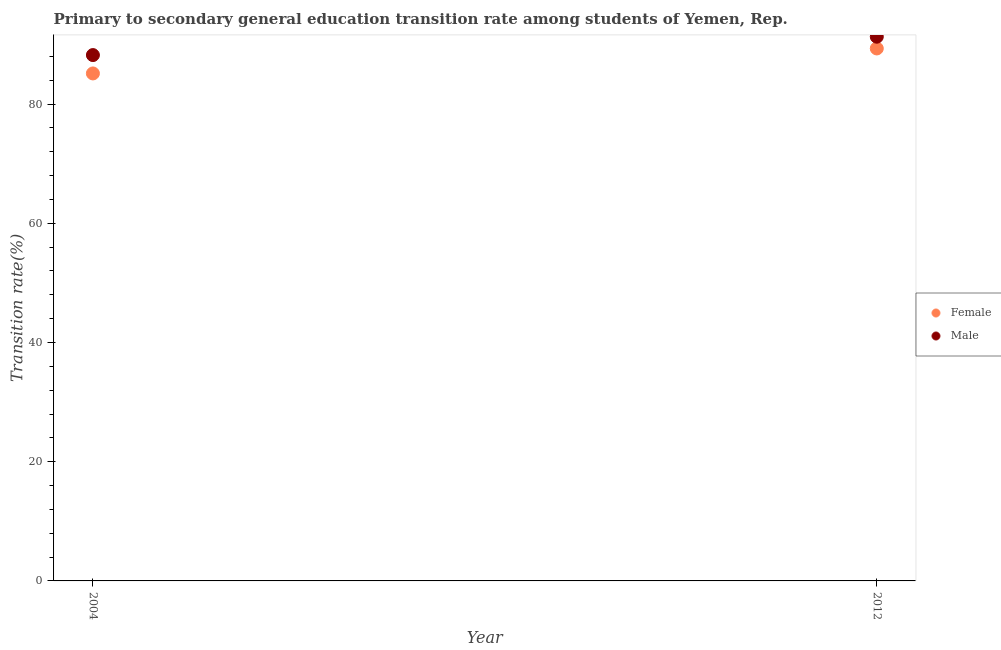How many different coloured dotlines are there?
Give a very brief answer. 2. What is the transition rate among male students in 2012?
Keep it short and to the point. 91.3. Across all years, what is the maximum transition rate among male students?
Provide a short and direct response. 91.3. Across all years, what is the minimum transition rate among male students?
Your answer should be very brief. 88.22. In which year was the transition rate among female students maximum?
Provide a short and direct response. 2012. What is the total transition rate among male students in the graph?
Keep it short and to the point. 179.51. What is the difference between the transition rate among male students in 2004 and that in 2012?
Your response must be concise. -3.08. What is the difference between the transition rate among male students in 2012 and the transition rate among female students in 2004?
Your answer should be very brief. 6.16. What is the average transition rate among male students per year?
Ensure brevity in your answer.  89.76. In the year 2012, what is the difference between the transition rate among male students and transition rate among female students?
Offer a very short reply. 1.97. In how many years, is the transition rate among female students greater than 60 %?
Make the answer very short. 2. What is the ratio of the transition rate among female students in 2004 to that in 2012?
Make the answer very short. 0.95. In how many years, is the transition rate among female students greater than the average transition rate among female students taken over all years?
Ensure brevity in your answer.  1. Does the transition rate among male students monotonically increase over the years?
Your answer should be very brief. Yes. Is the transition rate among female students strictly greater than the transition rate among male students over the years?
Keep it short and to the point. No. Is the transition rate among female students strictly less than the transition rate among male students over the years?
Give a very brief answer. Yes. Does the graph contain any zero values?
Your answer should be very brief. No. Where does the legend appear in the graph?
Your answer should be very brief. Center right. How many legend labels are there?
Give a very brief answer. 2. How are the legend labels stacked?
Give a very brief answer. Vertical. What is the title of the graph?
Keep it short and to the point. Primary to secondary general education transition rate among students of Yemen, Rep. Does "State government" appear as one of the legend labels in the graph?
Make the answer very short. No. What is the label or title of the X-axis?
Provide a short and direct response. Year. What is the label or title of the Y-axis?
Keep it short and to the point. Transition rate(%). What is the Transition rate(%) of Female in 2004?
Provide a short and direct response. 85.13. What is the Transition rate(%) in Male in 2004?
Your answer should be compact. 88.22. What is the Transition rate(%) in Female in 2012?
Make the answer very short. 89.32. What is the Transition rate(%) of Male in 2012?
Provide a succinct answer. 91.3. Across all years, what is the maximum Transition rate(%) in Female?
Ensure brevity in your answer.  89.32. Across all years, what is the maximum Transition rate(%) in Male?
Ensure brevity in your answer.  91.3. Across all years, what is the minimum Transition rate(%) in Female?
Offer a very short reply. 85.13. Across all years, what is the minimum Transition rate(%) of Male?
Give a very brief answer. 88.22. What is the total Transition rate(%) of Female in the graph?
Your response must be concise. 174.46. What is the total Transition rate(%) of Male in the graph?
Offer a very short reply. 179.51. What is the difference between the Transition rate(%) of Female in 2004 and that in 2012?
Your response must be concise. -4.19. What is the difference between the Transition rate(%) of Male in 2004 and that in 2012?
Provide a short and direct response. -3.08. What is the difference between the Transition rate(%) in Female in 2004 and the Transition rate(%) in Male in 2012?
Your answer should be very brief. -6.16. What is the average Transition rate(%) of Female per year?
Offer a very short reply. 87.23. What is the average Transition rate(%) in Male per year?
Your answer should be very brief. 89.76. In the year 2004, what is the difference between the Transition rate(%) of Female and Transition rate(%) of Male?
Make the answer very short. -3.08. In the year 2012, what is the difference between the Transition rate(%) of Female and Transition rate(%) of Male?
Give a very brief answer. -1.97. What is the ratio of the Transition rate(%) in Female in 2004 to that in 2012?
Keep it short and to the point. 0.95. What is the ratio of the Transition rate(%) of Male in 2004 to that in 2012?
Offer a very short reply. 0.97. What is the difference between the highest and the second highest Transition rate(%) in Female?
Your answer should be very brief. 4.19. What is the difference between the highest and the second highest Transition rate(%) in Male?
Make the answer very short. 3.08. What is the difference between the highest and the lowest Transition rate(%) of Female?
Provide a short and direct response. 4.19. What is the difference between the highest and the lowest Transition rate(%) of Male?
Provide a short and direct response. 3.08. 